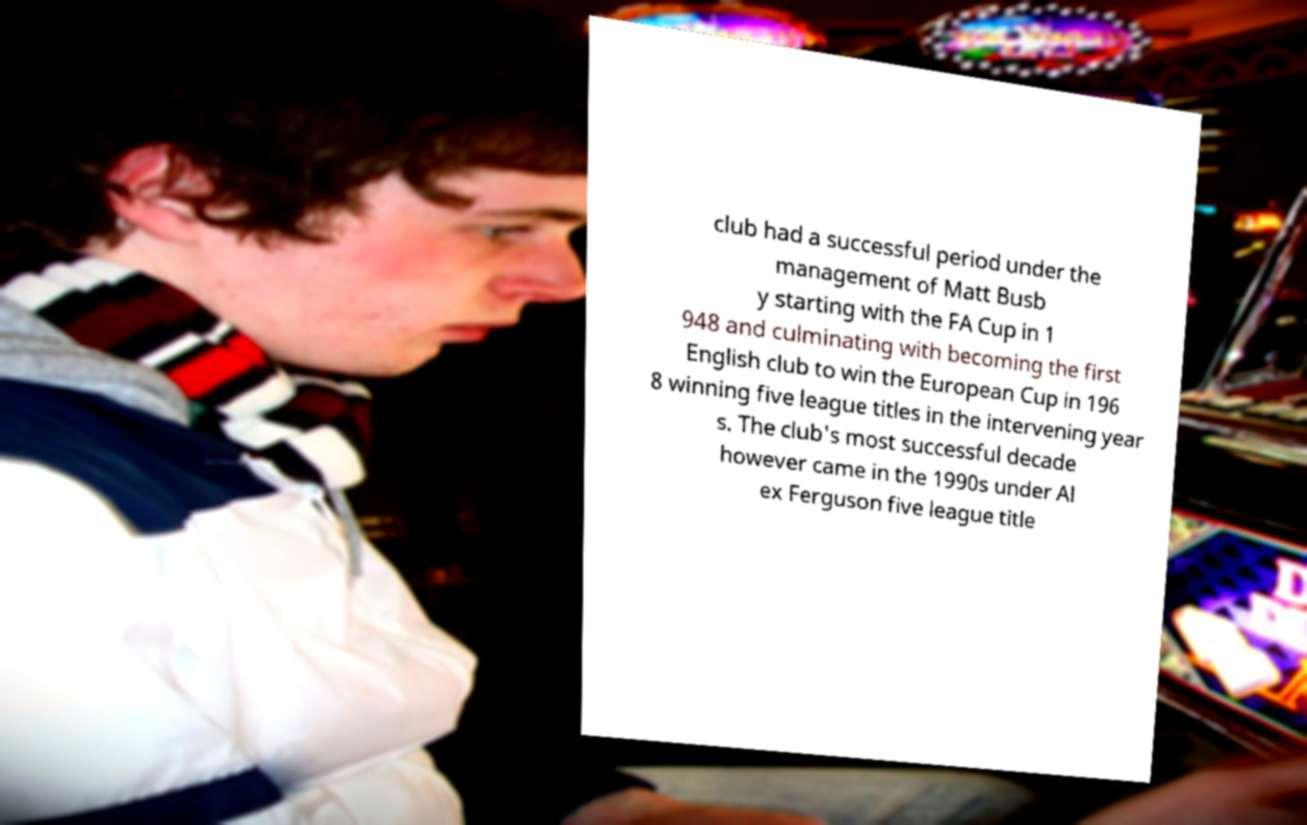Please identify and transcribe the text found in this image. club had a successful period under the management of Matt Busb y starting with the FA Cup in 1 948 and culminating with becoming the first English club to win the European Cup in 196 8 winning five league titles in the intervening year s. The club's most successful decade however came in the 1990s under Al ex Ferguson five league title 